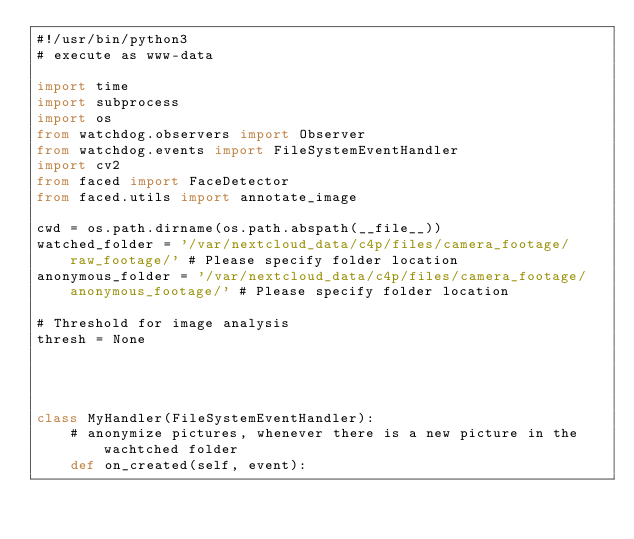<code> <loc_0><loc_0><loc_500><loc_500><_Python_>#!/usr/bin/python3
# execute as www-data

import time
import subprocess
import os
from watchdog.observers import Observer
from watchdog.events import FileSystemEventHandler
import cv2
from faced import FaceDetector
from faced.utils import annotate_image

cwd = os.path.dirname(os.path.abspath(__file__))
watched_folder = '/var/nextcloud_data/c4p/files/camera_footage/raw_footage/' # Please specify folder location
anonymous_folder = '/var/nextcloud_data/c4p/files/camera_footage/anonymous_footage/' # Please specify folder location

# Threshold for image analysis
thresh = None




class MyHandler(FileSystemEventHandler):
    # anonymize pictures, whenever there is a new picture in the wachtched folder
    def on_created(self, event):</code> 